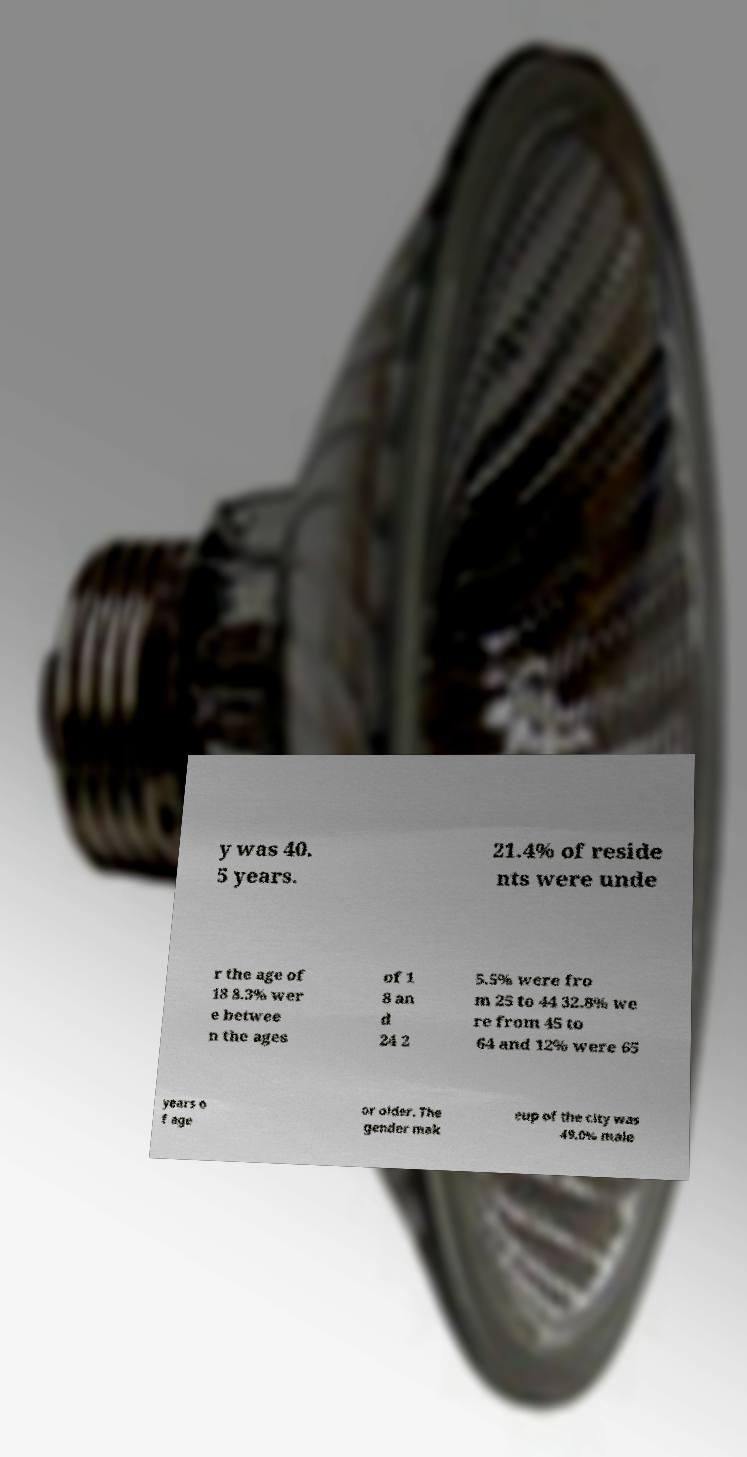Please read and relay the text visible in this image. What does it say? y was 40. 5 years. 21.4% of reside nts were unde r the age of 18 8.3% wer e betwee n the ages of 1 8 an d 24 2 5.5% were fro m 25 to 44 32.8% we re from 45 to 64 and 12% were 65 years o f age or older. The gender mak eup of the city was 49.0% male 